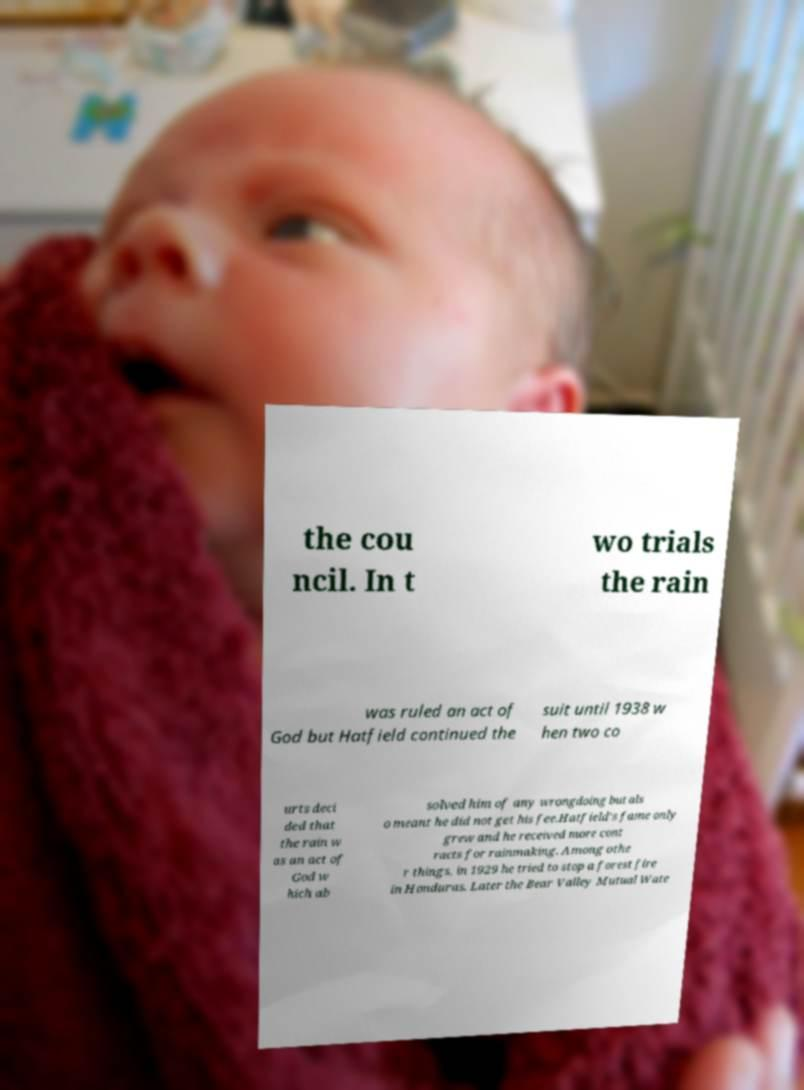Could you assist in decoding the text presented in this image and type it out clearly? the cou ncil. In t wo trials the rain was ruled an act of God but Hatfield continued the suit until 1938 w hen two co urts deci ded that the rain w as an act of God w hich ab solved him of any wrongdoing but als o meant he did not get his fee.Hatfield's fame only grew and he received more cont racts for rainmaking. Among othe r things, in 1929 he tried to stop a forest fire in Honduras. Later the Bear Valley Mutual Wate 